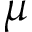Convert formula to latex. <formula><loc_0><loc_0><loc_500><loc_500>\mu</formula> 